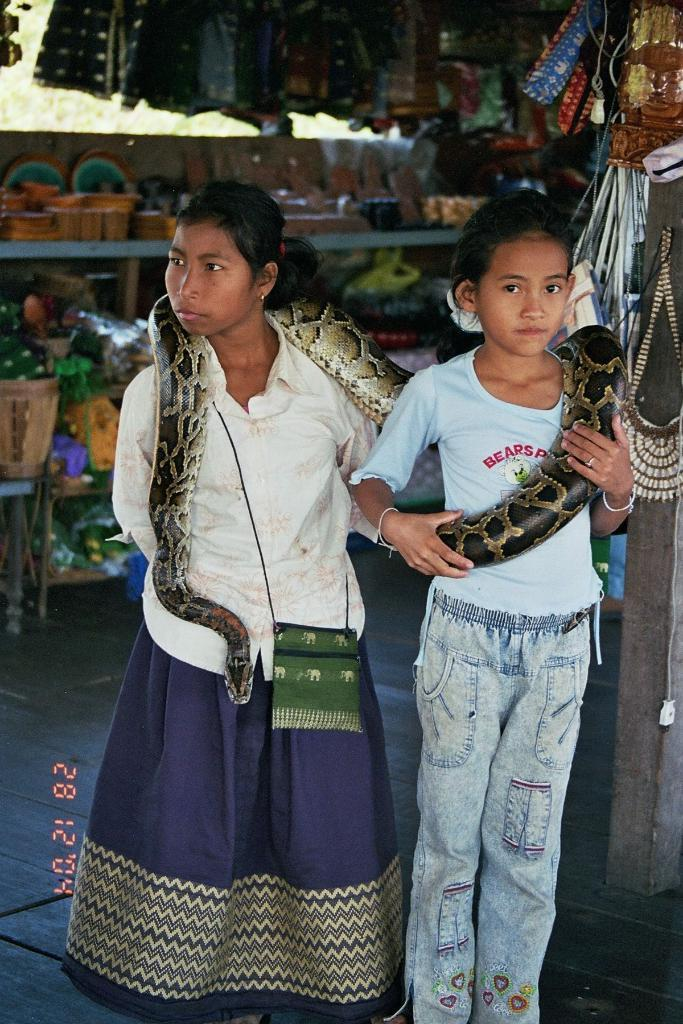How many people are in the image? There are two persons in the image. What are the persons doing in the image? The persons are carrying a snake. What can be seen in the background of the image? There are clothes and material stuff visible in the background. How many horses are visible in the image? There are no horses visible in the image. What type of pot is being used by the persons in the image? There is no pot present in the image; the persons are carrying a snake. 